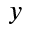Convert formula to latex. <formula><loc_0><loc_0><loc_500><loc_500>y</formula> 